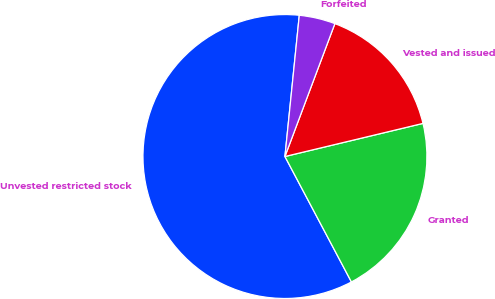Convert chart to OTSL. <chart><loc_0><loc_0><loc_500><loc_500><pie_chart><fcel>Unvested restricted stock<fcel>Granted<fcel>Vested and issued<fcel>Forfeited<nl><fcel>59.37%<fcel>20.99%<fcel>15.53%<fcel>4.11%<nl></chart> 